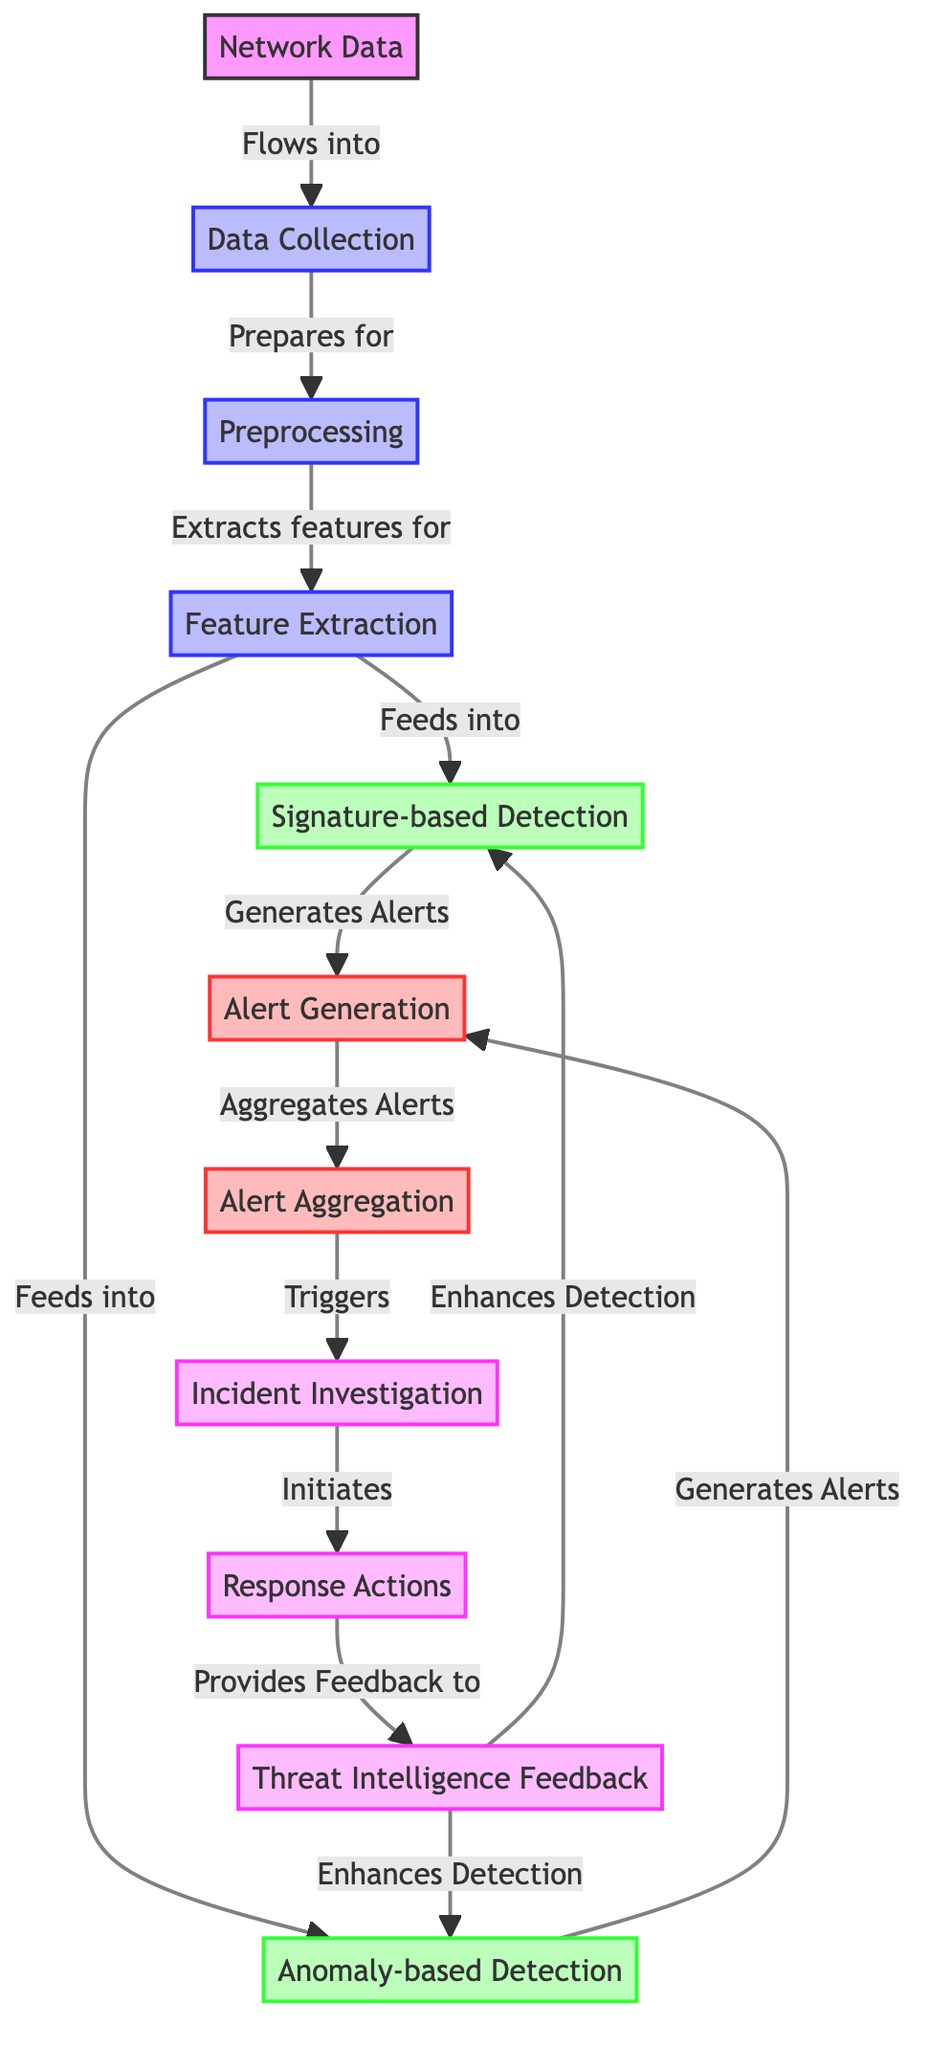What is the initial input to the workflow? The initial input provided in the diagram is "Network Data" which flows into the next step of data collection.
Answer: Network Data How many nodes are there in the diagram? The diagram contains a total of 11 nodes, each representing a distinct step or process in the intrusion detection workflow.
Answer: 11 What action follows "Alert Generation"? The action that directly follows "Alert Generation" is "Alert Aggregation", where the alerts generated are collected and prepared for the next stages.
Answer: Alert Aggregation Which node is responsible for generating alerts from both detection methods? "Alert Generation" generates alerts based on inputs from both "Signature-based Detection" and "Anomaly-based Detection."
Answer: Alert Generation What triggers the "Incident Investigation" node? "Alert Aggregation" triggers the "Incident Investigation" node by referring to the aggregated alerts collected from previous steps.
Answer: Alert Aggregation Which nodes enhance detection through feedback? "Threat Intelligence Feedback" enhances detection for both "Signature-based Detection" and "Anomaly-based Detection," showing a feedback loop in the diagram.
Answer: Signature-based Detection and Anomaly-based Detection What is the purpose of the "Data Collection" node? The "Data Collection" node prepares the incoming "Network Data" for subsequent processing, serving as a critical step before preprocessing occurs.
Answer: Prepares for How many edges are present in the diagram? There are a total of 12 edges in the diagram, which represent the various relationships and flow between the different nodes.
Answer: 12 What provides feedback to the response actions? The "Threat Intelligence Feedback" node provides feedback to the "Response Actions" node, which aids in improving and refining security responses.
Answer: Threat Intelligence Feedback What are the two detection methods outlined in the diagram? The two detection methods highlighted in the diagram are "Signature-based Detection" and "Anomaly-based Detection."
Answer: Signature-based Detection and Anomaly-based Detection 